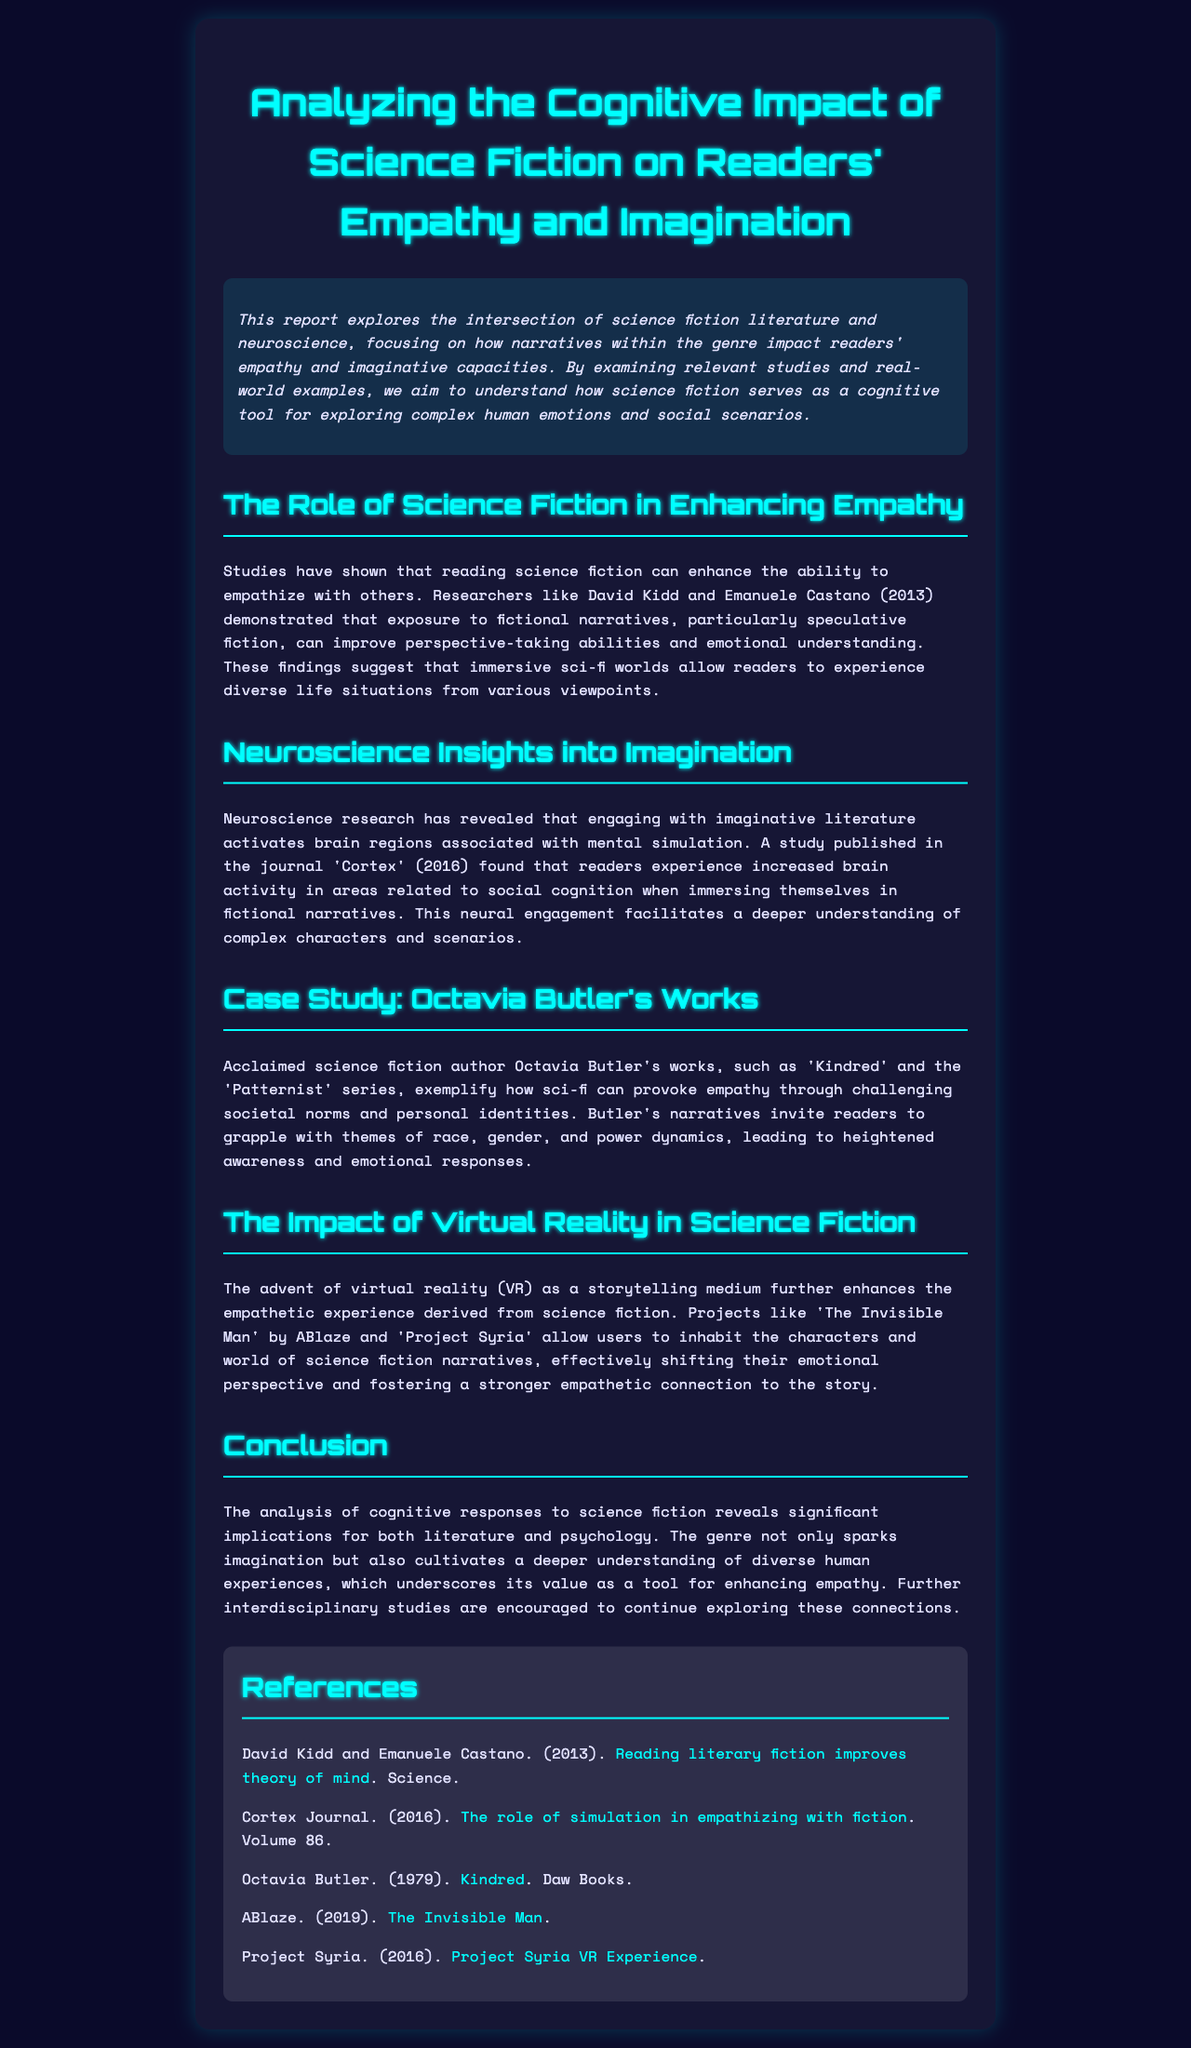What is the title of the report? The title is explicitly stated at the beginning of the document.
Answer: Analyzing the Cognitive Impact of Science Fiction on Readers' Empathy and Imagination Who are the researchers mentioned in the report? The report cites specific researchers linked to studies on empathy and fiction.
Answer: David Kidd and Emanuele Castano What year was the study published in Cortex? A specific publication year is given in the document regarding a neuroscience study related to fiction.
Answer: 2016 Which author’s works are used as a case study? The report highlights a specific author known for their influence in science fiction.
Answer: Octavia Butler What effect does reading science fiction have on empathy according to the findings? The findings highlight a key cognitive enhancement related to social interactions.
Answer: Enhances the ability to empathize What type of storytelling medium enhances empathetic experiences in science fiction? The report discusses a specific technological innovation used in storytelling.
Answer: Virtual Reality How does engaging with imaginative literature impact brain regions? The report describes a neural phenomenon linked to a specific cognitive process.
Answer: Activates brain regions associated with mental simulation What themes do Butler's narratives provoke readers to grapple with? The report lists thematic elements that enhance emotional and cognitive responses.
Answer: Race, gender, and power dynamics 